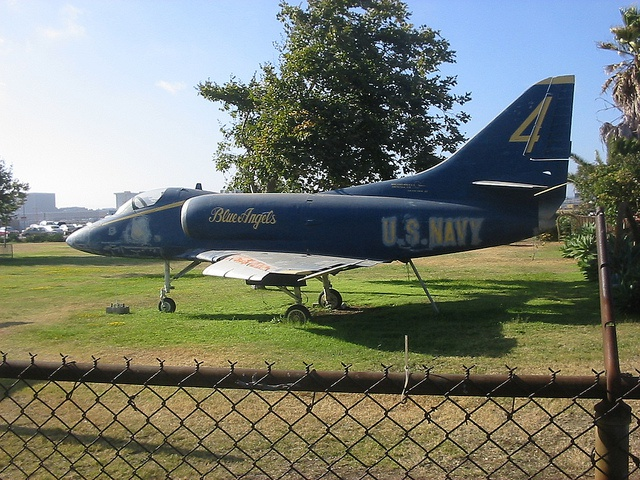Describe the objects in this image and their specific colors. I can see airplane in lavender, black, navy, gray, and blue tones, car in lavender, gray, and darkgray tones, car in lavender, white, darkgray, and gray tones, car in lavender, gray, darkgray, and black tones, and car in lavender, white, darkgray, and gray tones in this image. 